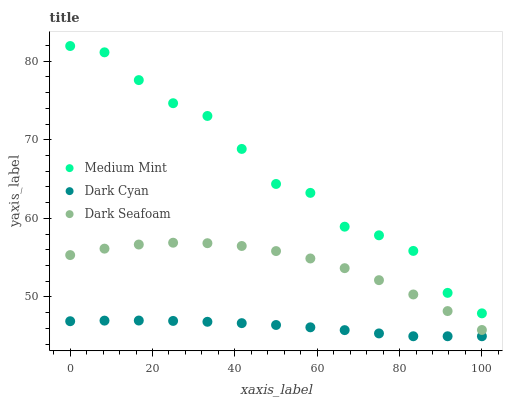Does Dark Cyan have the minimum area under the curve?
Answer yes or no. Yes. Does Medium Mint have the maximum area under the curve?
Answer yes or no. Yes. Does Dark Seafoam have the minimum area under the curve?
Answer yes or no. No. Does Dark Seafoam have the maximum area under the curve?
Answer yes or no. No. Is Dark Cyan the smoothest?
Answer yes or no. Yes. Is Medium Mint the roughest?
Answer yes or no. Yes. Is Dark Seafoam the smoothest?
Answer yes or no. No. Is Dark Seafoam the roughest?
Answer yes or no. No. Does Dark Cyan have the lowest value?
Answer yes or no. Yes. Does Dark Seafoam have the lowest value?
Answer yes or no. No. Does Medium Mint have the highest value?
Answer yes or no. Yes. Does Dark Seafoam have the highest value?
Answer yes or no. No. Is Dark Cyan less than Medium Mint?
Answer yes or no. Yes. Is Medium Mint greater than Dark Cyan?
Answer yes or no. Yes. Does Dark Cyan intersect Medium Mint?
Answer yes or no. No. 